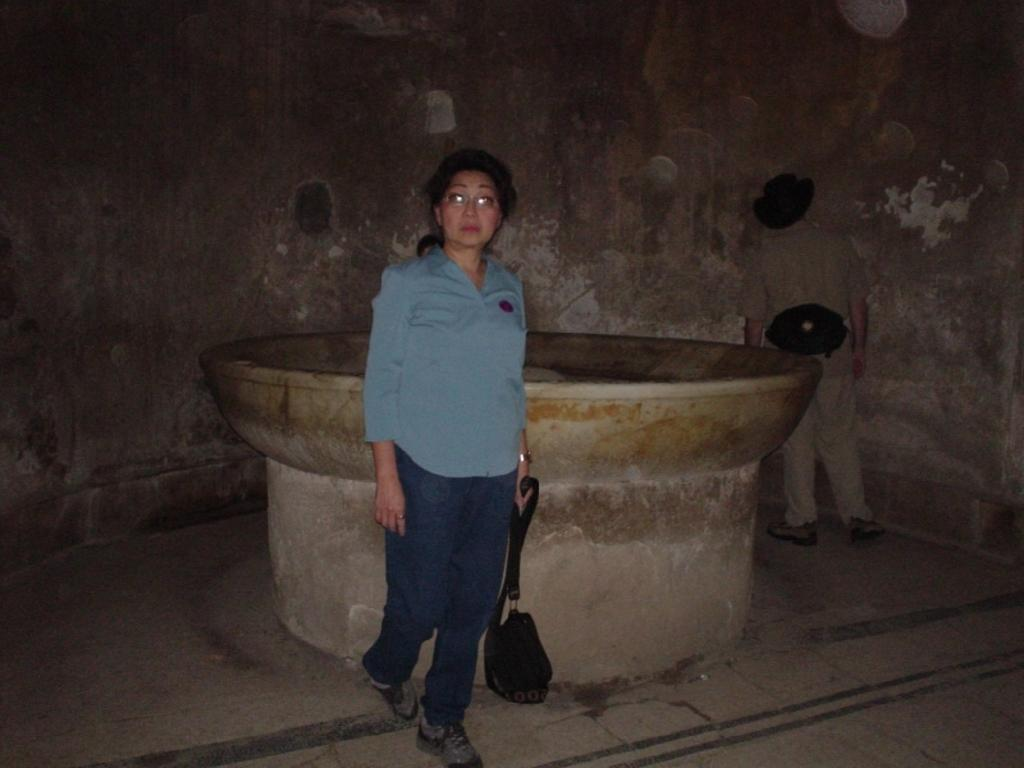How many people are present in the image? There are two people standing in the image. What is the lady holding in the image? The lady is holding a bag. What can be seen in the background of the image? There is a fountain and a wall in the background of the image. What type of space suit is the man wearing in the image? There is no space suit or any reference to space in the image; it features two people standing with a lady holding a bag. How many eggs are visible in the image? There are no eggs present in the image. 